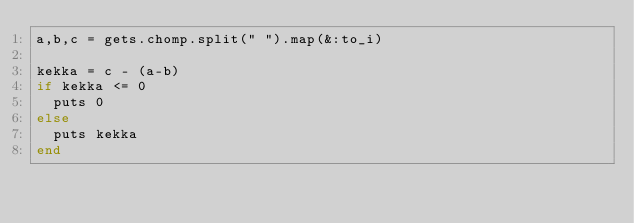Convert code to text. <code><loc_0><loc_0><loc_500><loc_500><_Ruby_>a,b,c = gets.chomp.split(" ").map(&:to_i)

kekka = c - (a-b)
if kekka <= 0
  puts 0
else
  puts kekka
end</code> 